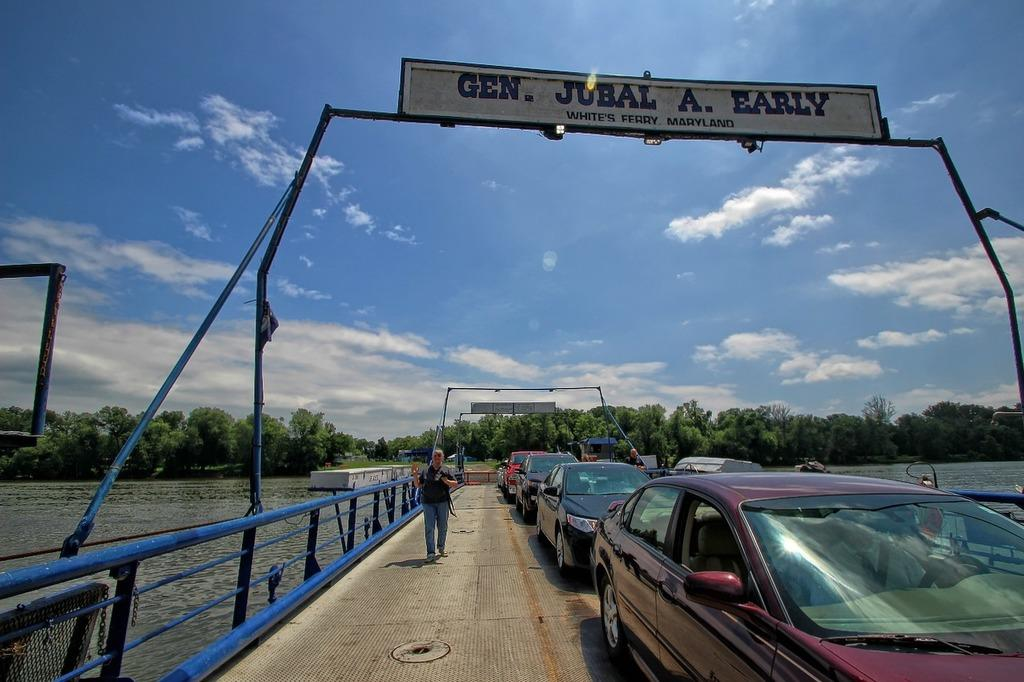<image>
Render a clear and concise summary of the photo. many cars that are under a jubal sign 